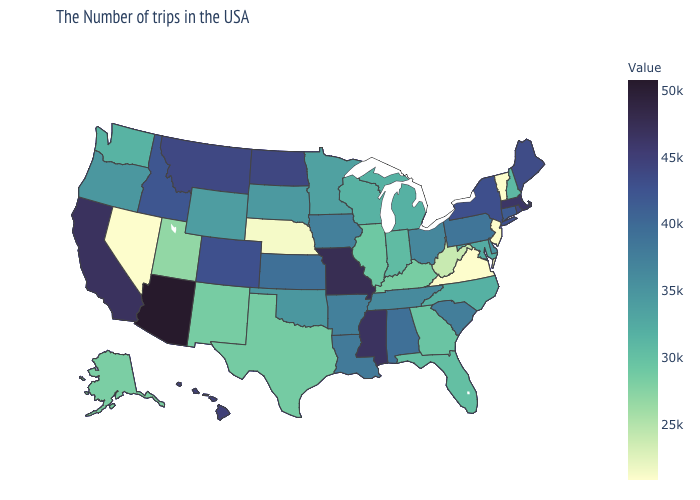Among the states that border Oregon , does Washington have the lowest value?
Give a very brief answer. No. Among the states that border Colorado , which have the highest value?
Concise answer only. Arizona. Among the states that border Wisconsin , does Iowa have the lowest value?
Answer briefly. No. Is the legend a continuous bar?
Concise answer only. Yes. Among the states that border Vermont , does New Hampshire have the highest value?
Write a very short answer. No. Which states have the lowest value in the West?
Keep it brief. Nevada. Which states hav the highest value in the South?
Keep it brief. Mississippi. Which states hav the highest value in the MidWest?
Quick response, please. Missouri. 